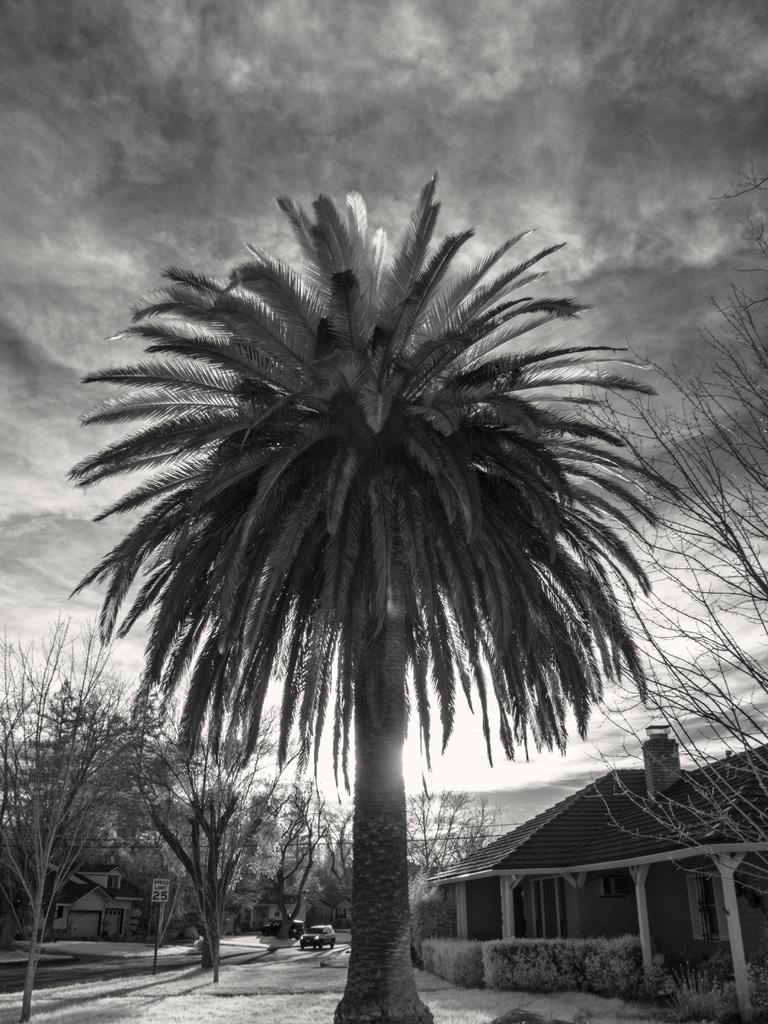What is the color scheme of the image? The image is black and white. What type of structures can be seen in the image? There are buildings in the image. What other natural elements are present in the image? There are trees in the image. What is happening on the road in the image? A vehicle is moving on the road in the image. What can be seen in the background of the image? The sky is visible in the background of the image. How many ladybugs are crawling on the buildings in the image? There are no ladybugs present in the image; it features buildings, trees, a moving vehicle, and a black and white color scheme. 